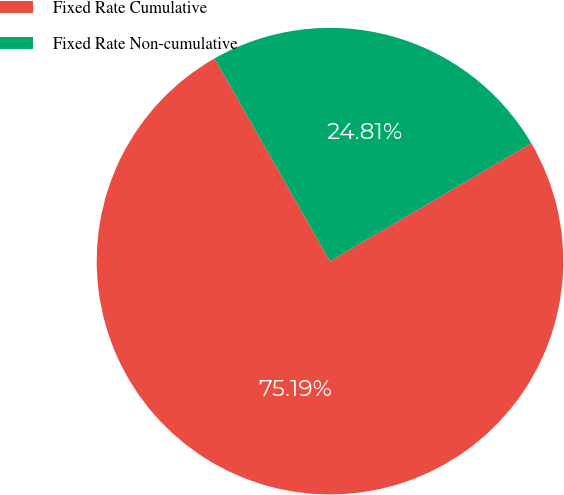Convert chart to OTSL. <chart><loc_0><loc_0><loc_500><loc_500><pie_chart><fcel>Fixed Rate Cumulative<fcel>Fixed Rate Non-cumulative<nl><fcel>75.19%<fcel>24.81%<nl></chart> 